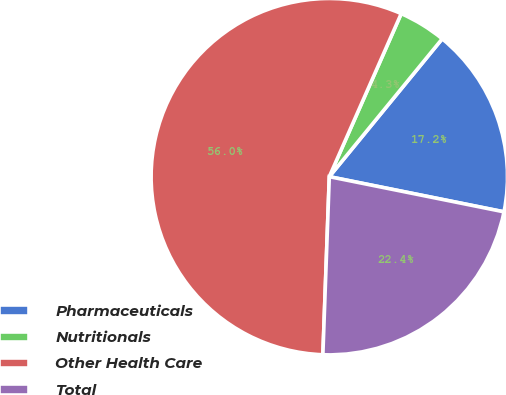<chart> <loc_0><loc_0><loc_500><loc_500><pie_chart><fcel>Pharmaceuticals<fcel>Nutritionals<fcel>Other Health Care<fcel>Total<nl><fcel>17.24%<fcel>4.31%<fcel>56.03%<fcel>22.41%<nl></chart> 